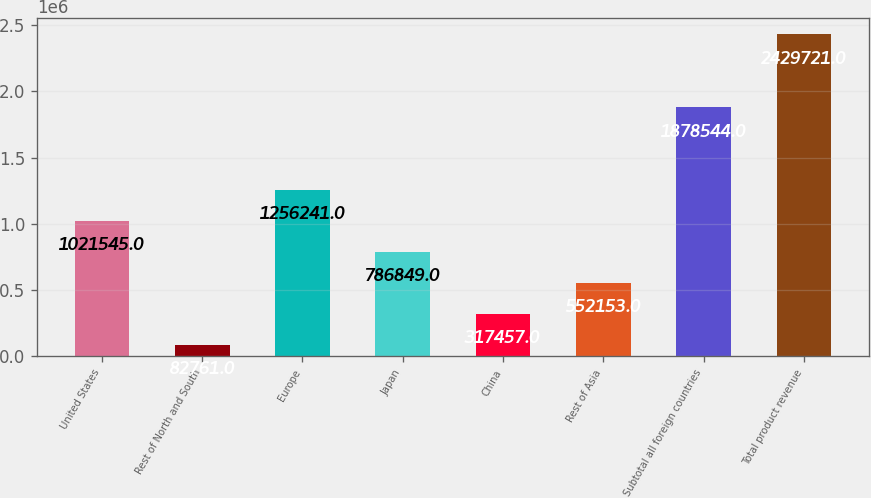Convert chart. <chart><loc_0><loc_0><loc_500><loc_500><bar_chart><fcel>United States<fcel>Rest of North and South<fcel>Europe<fcel>Japan<fcel>China<fcel>Rest of Asia<fcel>Subtotal all foreign countries<fcel>Total product revenue<nl><fcel>1.02154e+06<fcel>82761<fcel>1.25624e+06<fcel>786849<fcel>317457<fcel>552153<fcel>1.87854e+06<fcel>2.42972e+06<nl></chart> 